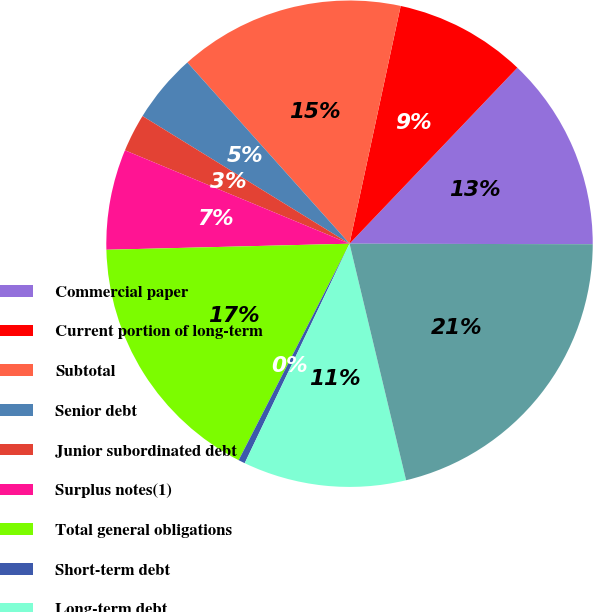Convert chart to OTSL. <chart><loc_0><loc_0><loc_500><loc_500><pie_chart><fcel>Commercial paper<fcel>Current portion of long-term<fcel>Subtotal<fcel>Senior debt<fcel>Junior subordinated debt<fcel>Surplus notes(1)<fcel>Total general obligations<fcel>Short-term debt<fcel>Long-term debt<fcel>Total borrowings<nl><fcel>12.91%<fcel>8.75%<fcel>14.99%<fcel>4.59%<fcel>2.52%<fcel>6.67%<fcel>17.07%<fcel>0.44%<fcel>10.83%<fcel>21.23%<nl></chart> 